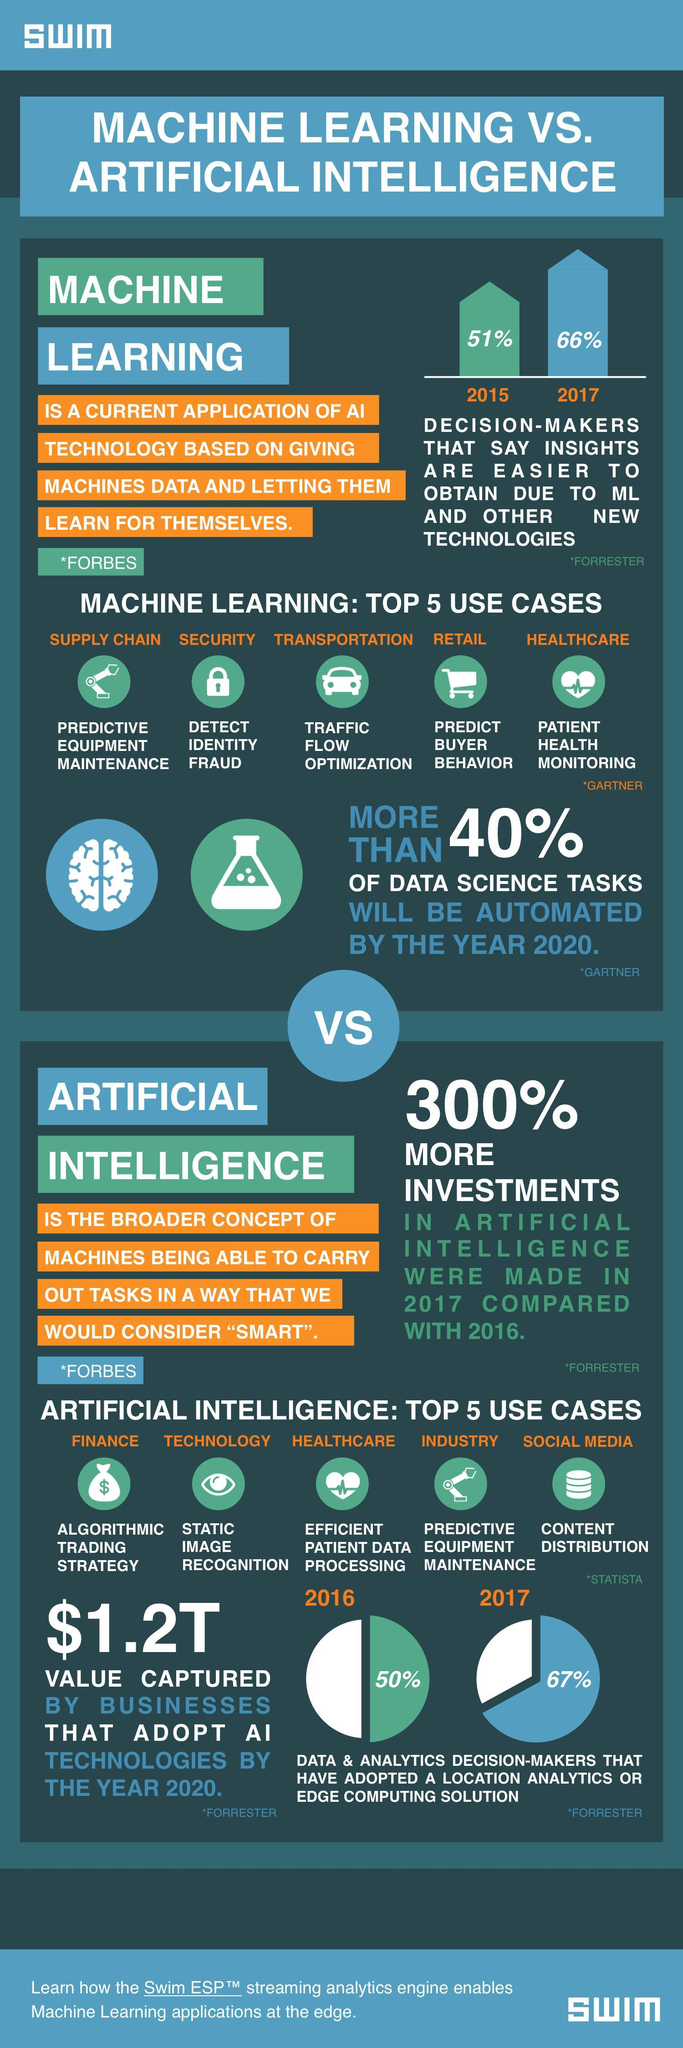In 2017 what percent of decision-makers felt that machine learning made it easier to obtain insights?
Answer the question with a short phrase. 66% What is AI used in the industry for? Predictive equipment maintenance Which are the top 3 use cases of AI? Finance, technology, healthcare What is AI used in social media for? Content distribution Which are the top 3 use cases in machine learning? Supply chain, security, transportation What is ML used in  transportation for? Traffic flow optimization What is  ML used in retail for? Predict buyer behaviour What is AI used in technology for? Static image recognition What is machine learning used in healthcare for? Patient health monitoring What is the percentage of increase in investments in AI in 2017? 300% How much will the businesses that use AI technologies gain by 2020 ($)? 1.2T What is the term used for machines doing their tasks in a way that makes them smart - AI, ML or SMART? AI 